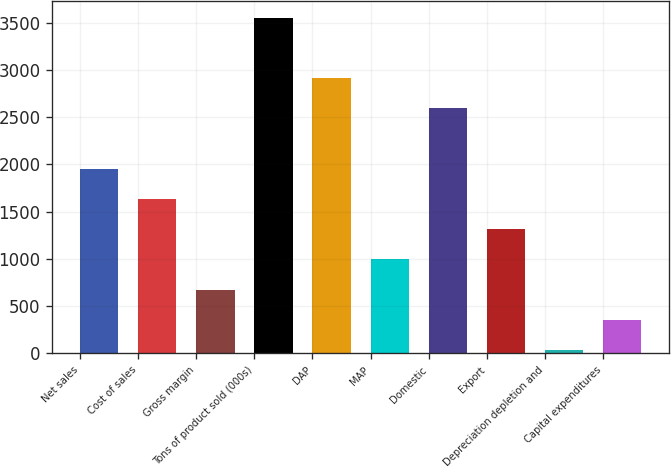Convert chart. <chart><loc_0><loc_0><loc_500><loc_500><bar_chart><fcel>Net sales<fcel>Cost of sales<fcel>Gross margin<fcel>Tons of product sold (000s)<fcel>DAP<fcel>MAP<fcel>Domestic<fcel>Export<fcel>Depreciation depletion and<fcel>Capital expenditures<nl><fcel>1952.4<fcel>1632.25<fcel>671.8<fcel>3553.15<fcel>2912.85<fcel>991.95<fcel>2592.7<fcel>1312.1<fcel>31.5<fcel>351.65<nl></chart> 